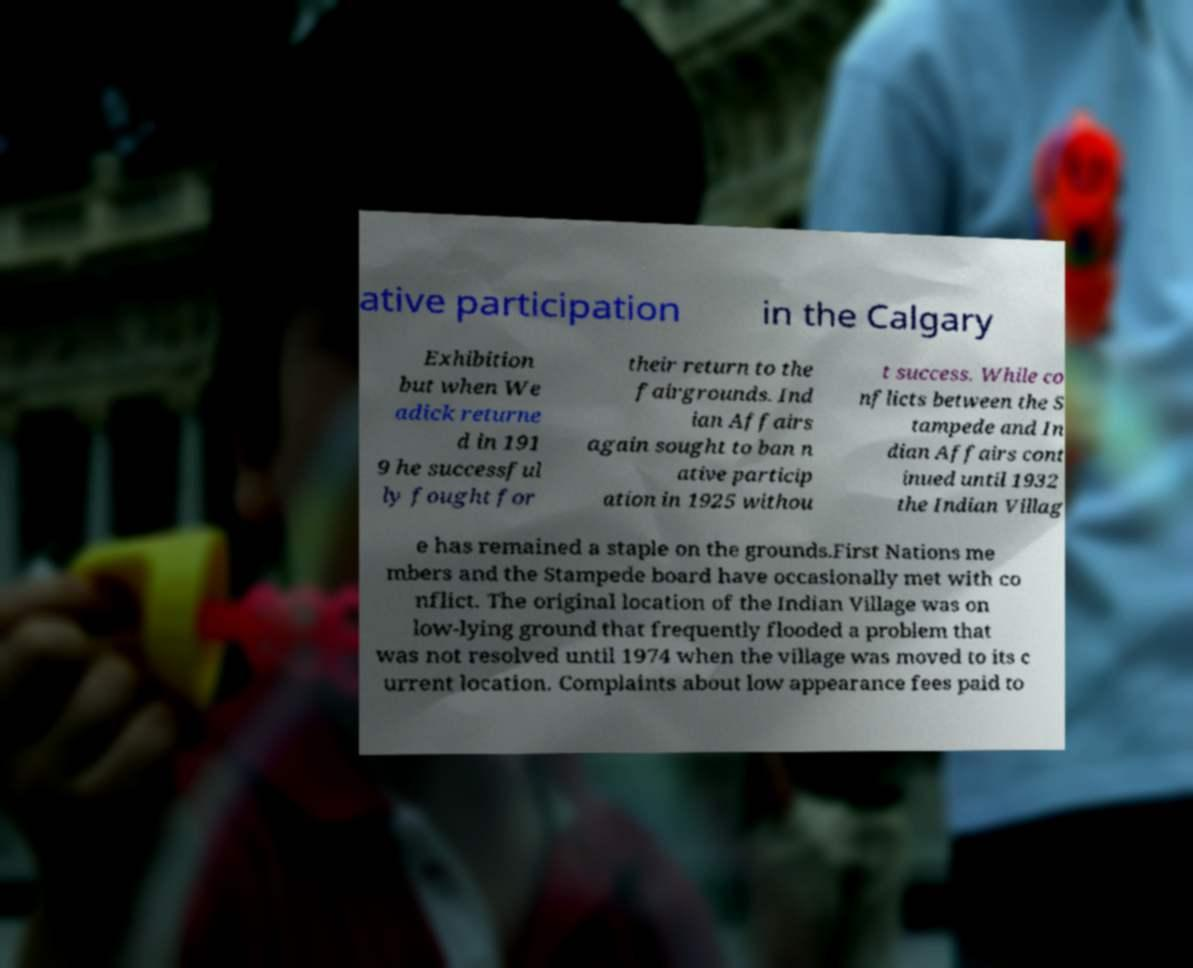Can you read and provide the text displayed in the image?This photo seems to have some interesting text. Can you extract and type it out for me? ative participation in the Calgary Exhibition but when We adick returne d in 191 9 he successful ly fought for their return to the fairgrounds. Ind ian Affairs again sought to ban n ative particip ation in 1925 withou t success. While co nflicts between the S tampede and In dian Affairs cont inued until 1932 the Indian Villag e has remained a staple on the grounds.First Nations me mbers and the Stampede board have occasionally met with co nflict. The original location of the Indian Village was on low-lying ground that frequently flooded a problem that was not resolved until 1974 when the village was moved to its c urrent location. Complaints about low appearance fees paid to 